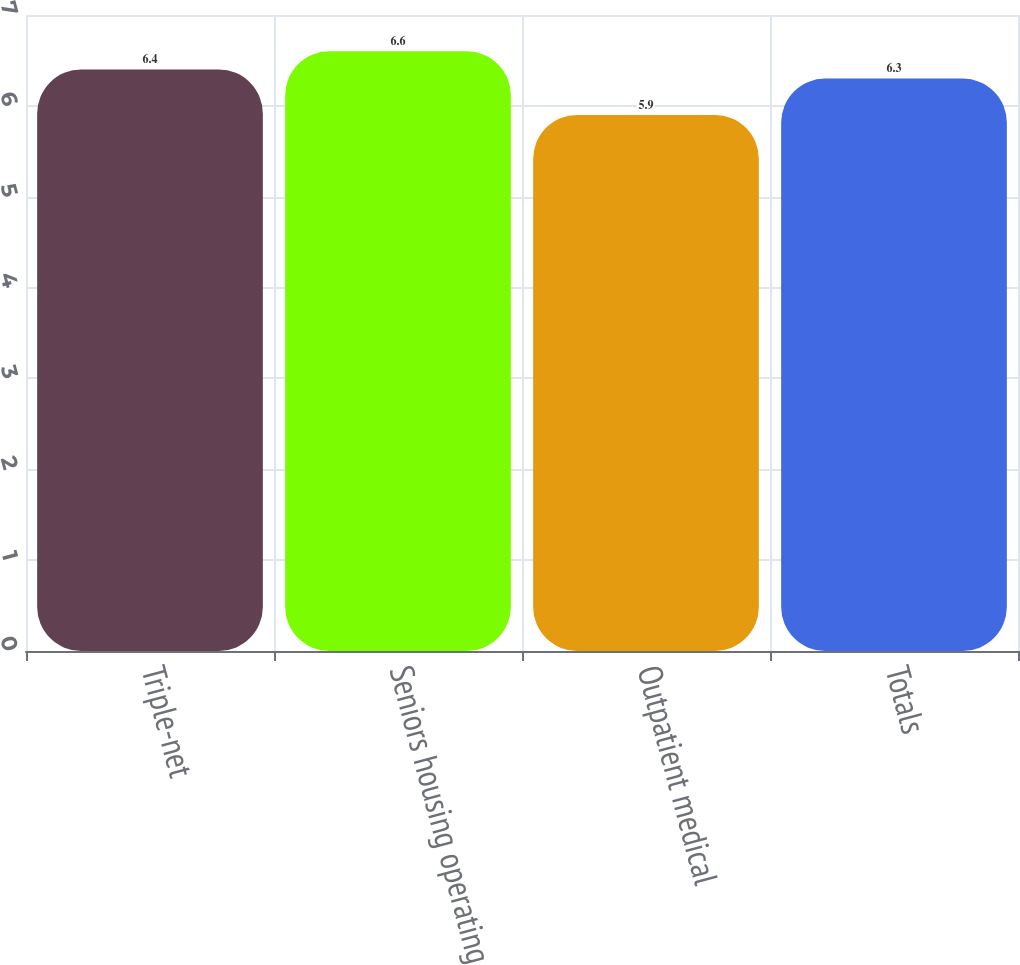Convert chart. <chart><loc_0><loc_0><loc_500><loc_500><bar_chart><fcel>Triple-net<fcel>Seniors housing operating<fcel>Outpatient medical<fcel>Totals<nl><fcel>6.4<fcel>6.6<fcel>5.9<fcel>6.3<nl></chart> 